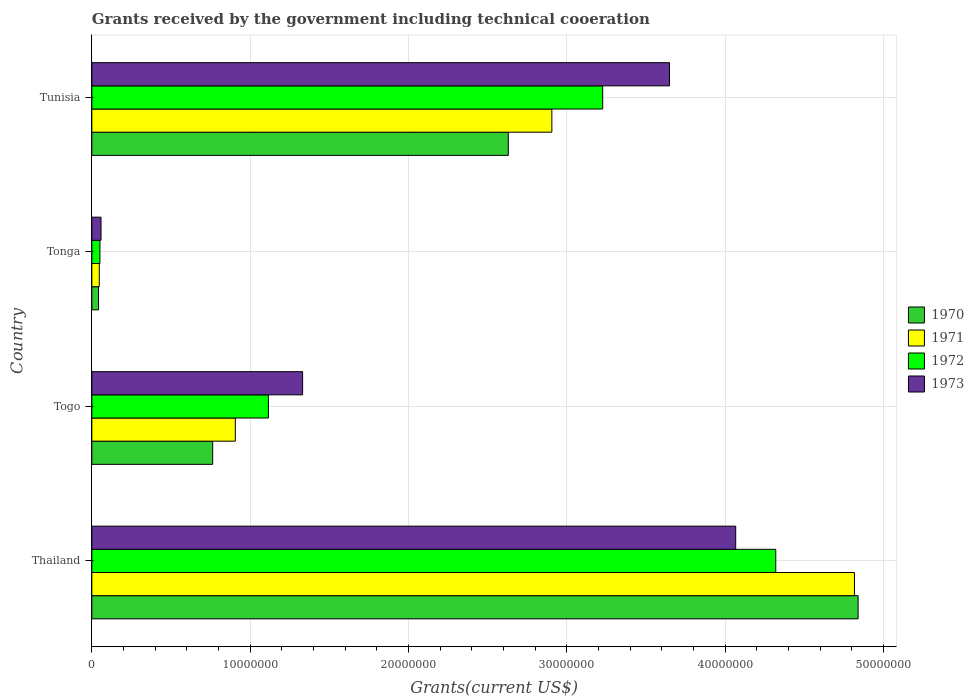How many different coloured bars are there?
Your response must be concise. 4. How many groups of bars are there?
Offer a very short reply. 4. Are the number of bars on each tick of the Y-axis equal?
Make the answer very short. Yes. How many bars are there on the 1st tick from the bottom?
Keep it short and to the point. 4. What is the label of the 1st group of bars from the top?
Keep it short and to the point. Tunisia. What is the total grants received by the government in 1972 in Thailand?
Your answer should be very brief. 4.32e+07. Across all countries, what is the maximum total grants received by the government in 1970?
Provide a short and direct response. 4.84e+07. Across all countries, what is the minimum total grants received by the government in 1973?
Make the answer very short. 5.80e+05. In which country was the total grants received by the government in 1972 maximum?
Offer a very short reply. Thailand. In which country was the total grants received by the government in 1973 minimum?
Offer a very short reply. Tonga. What is the total total grants received by the government in 1973 in the graph?
Provide a short and direct response. 9.10e+07. What is the difference between the total grants received by the government in 1972 in Thailand and that in Tunisia?
Provide a short and direct response. 1.09e+07. What is the difference between the total grants received by the government in 1971 in Tonga and the total grants received by the government in 1973 in Thailand?
Give a very brief answer. -4.02e+07. What is the average total grants received by the government in 1970 per country?
Offer a very short reply. 2.07e+07. What is the difference between the total grants received by the government in 1972 and total grants received by the government in 1970 in Togo?
Provide a succinct answer. 3.52e+06. In how many countries, is the total grants received by the government in 1972 greater than 28000000 US$?
Give a very brief answer. 2. What is the ratio of the total grants received by the government in 1972 in Tonga to that in Tunisia?
Provide a short and direct response. 0.02. Is the total grants received by the government in 1973 in Togo less than that in Tunisia?
Offer a very short reply. Yes. Is the difference between the total grants received by the government in 1972 in Tonga and Tunisia greater than the difference between the total grants received by the government in 1970 in Tonga and Tunisia?
Your answer should be very brief. No. What is the difference between the highest and the second highest total grants received by the government in 1973?
Provide a short and direct response. 4.18e+06. What is the difference between the highest and the lowest total grants received by the government in 1973?
Your answer should be compact. 4.01e+07. In how many countries, is the total grants received by the government in 1970 greater than the average total grants received by the government in 1970 taken over all countries?
Give a very brief answer. 2. Is the sum of the total grants received by the government in 1973 in Thailand and Togo greater than the maximum total grants received by the government in 1970 across all countries?
Provide a succinct answer. Yes. Is it the case that in every country, the sum of the total grants received by the government in 1973 and total grants received by the government in 1972 is greater than the sum of total grants received by the government in 1970 and total grants received by the government in 1971?
Your answer should be very brief. No. What does the 2nd bar from the bottom in Thailand represents?
Provide a succinct answer. 1971. Is it the case that in every country, the sum of the total grants received by the government in 1972 and total grants received by the government in 1971 is greater than the total grants received by the government in 1973?
Your response must be concise. Yes. How many bars are there?
Make the answer very short. 16. Are all the bars in the graph horizontal?
Your answer should be very brief. Yes. What is the difference between two consecutive major ticks on the X-axis?
Make the answer very short. 1.00e+07. Does the graph contain any zero values?
Provide a succinct answer. No. How many legend labels are there?
Keep it short and to the point. 4. What is the title of the graph?
Your answer should be compact. Grants received by the government including technical cooeration. What is the label or title of the X-axis?
Your answer should be compact. Grants(current US$). What is the Grants(current US$) in 1970 in Thailand?
Give a very brief answer. 4.84e+07. What is the Grants(current US$) in 1971 in Thailand?
Keep it short and to the point. 4.82e+07. What is the Grants(current US$) of 1972 in Thailand?
Your answer should be compact. 4.32e+07. What is the Grants(current US$) in 1973 in Thailand?
Your response must be concise. 4.07e+07. What is the Grants(current US$) of 1970 in Togo?
Your answer should be very brief. 7.63e+06. What is the Grants(current US$) of 1971 in Togo?
Make the answer very short. 9.06e+06. What is the Grants(current US$) in 1972 in Togo?
Offer a terse response. 1.12e+07. What is the Grants(current US$) of 1973 in Togo?
Make the answer very short. 1.33e+07. What is the Grants(current US$) of 1970 in Tonga?
Make the answer very short. 4.20e+05. What is the Grants(current US$) in 1972 in Tonga?
Make the answer very short. 5.10e+05. What is the Grants(current US$) of 1973 in Tonga?
Provide a short and direct response. 5.80e+05. What is the Grants(current US$) of 1970 in Tunisia?
Give a very brief answer. 2.63e+07. What is the Grants(current US$) in 1971 in Tunisia?
Provide a short and direct response. 2.90e+07. What is the Grants(current US$) of 1972 in Tunisia?
Your answer should be compact. 3.23e+07. What is the Grants(current US$) of 1973 in Tunisia?
Offer a very short reply. 3.65e+07. Across all countries, what is the maximum Grants(current US$) in 1970?
Ensure brevity in your answer.  4.84e+07. Across all countries, what is the maximum Grants(current US$) in 1971?
Keep it short and to the point. 4.82e+07. Across all countries, what is the maximum Grants(current US$) in 1972?
Your answer should be compact. 4.32e+07. Across all countries, what is the maximum Grants(current US$) of 1973?
Provide a succinct answer. 4.07e+07. Across all countries, what is the minimum Grants(current US$) in 1971?
Offer a terse response. 4.70e+05. Across all countries, what is the minimum Grants(current US$) of 1972?
Offer a terse response. 5.10e+05. Across all countries, what is the minimum Grants(current US$) in 1973?
Offer a very short reply. 5.80e+05. What is the total Grants(current US$) in 1970 in the graph?
Your answer should be compact. 8.27e+07. What is the total Grants(current US$) of 1971 in the graph?
Offer a very short reply. 8.67e+07. What is the total Grants(current US$) in 1972 in the graph?
Provide a short and direct response. 8.71e+07. What is the total Grants(current US$) of 1973 in the graph?
Make the answer very short. 9.10e+07. What is the difference between the Grants(current US$) of 1970 in Thailand and that in Togo?
Provide a short and direct response. 4.08e+07. What is the difference between the Grants(current US$) in 1971 in Thailand and that in Togo?
Provide a succinct answer. 3.91e+07. What is the difference between the Grants(current US$) in 1972 in Thailand and that in Togo?
Ensure brevity in your answer.  3.20e+07. What is the difference between the Grants(current US$) in 1973 in Thailand and that in Togo?
Ensure brevity in your answer.  2.74e+07. What is the difference between the Grants(current US$) in 1970 in Thailand and that in Tonga?
Provide a short and direct response. 4.80e+07. What is the difference between the Grants(current US$) of 1971 in Thailand and that in Tonga?
Your answer should be compact. 4.77e+07. What is the difference between the Grants(current US$) of 1972 in Thailand and that in Tonga?
Your response must be concise. 4.27e+07. What is the difference between the Grants(current US$) in 1973 in Thailand and that in Tonga?
Provide a short and direct response. 4.01e+07. What is the difference between the Grants(current US$) of 1970 in Thailand and that in Tunisia?
Your response must be concise. 2.21e+07. What is the difference between the Grants(current US$) in 1971 in Thailand and that in Tunisia?
Offer a very short reply. 1.91e+07. What is the difference between the Grants(current US$) of 1972 in Thailand and that in Tunisia?
Provide a succinct answer. 1.09e+07. What is the difference between the Grants(current US$) of 1973 in Thailand and that in Tunisia?
Give a very brief answer. 4.18e+06. What is the difference between the Grants(current US$) of 1970 in Togo and that in Tonga?
Your response must be concise. 7.21e+06. What is the difference between the Grants(current US$) in 1971 in Togo and that in Tonga?
Your answer should be very brief. 8.59e+06. What is the difference between the Grants(current US$) of 1972 in Togo and that in Tonga?
Give a very brief answer. 1.06e+07. What is the difference between the Grants(current US$) in 1973 in Togo and that in Tonga?
Your answer should be compact. 1.27e+07. What is the difference between the Grants(current US$) in 1970 in Togo and that in Tunisia?
Your answer should be compact. -1.87e+07. What is the difference between the Grants(current US$) of 1971 in Togo and that in Tunisia?
Provide a short and direct response. -2.00e+07. What is the difference between the Grants(current US$) of 1972 in Togo and that in Tunisia?
Ensure brevity in your answer.  -2.11e+07. What is the difference between the Grants(current US$) of 1973 in Togo and that in Tunisia?
Your answer should be very brief. -2.32e+07. What is the difference between the Grants(current US$) of 1970 in Tonga and that in Tunisia?
Give a very brief answer. -2.59e+07. What is the difference between the Grants(current US$) in 1971 in Tonga and that in Tunisia?
Offer a terse response. -2.86e+07. What is the difference between the Grants(current US$) of 1972 in Tonga and that in Tunisia?
Provide a succinct answer. -3.18e+07. What is the difference between the Grants(current US$) of 1973 in Tonga and that in Tunisia?
Offer a terse response. -3.59e+07. What is the difference between the Grants(current US$) in 1970 in Thailand and the Grants(current US$) in 1971 in Togo?
Give a very brief answer. 3.93e+07. What is the difference between the Grants(current US$) in 1970 in Thailand and the Grants(current US$) in 1972 in Togo?
Your answer should be compact. 3.72e+07. What is the difference between the Grants(current US$) in 1970 in Thailand and the Grants(current US$) in 1973 in Togo?
Provide a short and direct response. 3.51e+07. What is the difference between the Grants(current US$) of 1971 in Thailand and the Grants(current US$) of 1972 in Togo?
Keep it short and to the point. 3.70e+07. What is the difference between the Grants(current US$) of 1971 in Thailand and the Grants(current US$) of 1973 in Togo?
Your answer should be compact. 3.48e+07. What is the difference between the Grants(current US$) of 1972 in Thailand and the Grants(current US$) of 1973 in Togo?
Ensure brevity in your answer.  2.99e+07. What is the difference between the Grants(current US$) in 1970 in Thailand and the Grants(current US$) in 1971 in Tonga?
Offer a very short reply. 4.79e+07. What is the difference between the Grants(current US$) of 1970 in Thailand and the Grants(current US$) of 1972 in Tonga?
Provide a succinct answer. 4.79e+07. What is the difference between the Grants(current US$) in 1970 in Thailand and the Grants(current US$) in 1973 in Tonga?
Offer a terse response. 4.78e+07. What is the difference between the Grants(current US$) in 1971 in Thailand and the Grants(current US$) in 1972 in Tonga?
Your answer should be compact. 4.76e+07. What is the difference between the Grants(current US$) in 1971 in Thailand and the Grants(current US$) in 1973 in Tonga?
Give a very brief answer. 4.76e+07. What is the difference between the Grants(current US$) in 1972 in Thailand and the Grants(current US$) in 1973 in Tonga?
Your answer should be very brief. 4.26e+07. What is the difference between the Grants(current US$) in 1970 in Thailand and the Grants(current US$) in 1971 in Tunisia?
Offer a terse response. 1.93e+07. What is the difference between the Grants(current US$) of 1970 in Thailand and the Grants(current US$) of 1972 in Tunisia?
Keep it short and to the point. 1.61e+07. What is the difference between the Grants(current US$) of 1970 in Thailand and the Grants(current US$) of 1973 in Tunisia?
Provide a succinct answer. 1.19e+07. What is the difference between the Grants(current US$) in 1971 in Thailand and the Grants(current US$) in 1972 in Tunisia?
Ensure brevity in your answer.  1.59e+07. What is the difference between the Grants(current US$) of 1971 in Thailand and the Grants(current US$) of 1973 in Tunisia?
Ensure brevity in your answer.  1.17e+07. What is the difference between the Grants(current US$) in 1972 in Thailand and the Grants(current US$) in 1973 in Tunisia?
Offer a terse response. 6.71e+06. What is the difference between the Grants(current US$) in 1970 in Togo and the Grants(current US$) in 1971 in Tonga?
Offer a terse response. 7.16e+06. What is the difference between the Grants(current US$) of 1970 in Togo and the Grants(current US$) of 1972 in Tonga?
Provide a short and direct response. 7.12e+06. What is the difference between the Grants(current US$) of 1970 in Togo and the Grants(current US$) of 1973 in Tonga?
Ensure brevity in your answer.  7.05e+06. What is the difference between the Grants(current US$) of 1971 in Togo and the Grants(current US$) of 1972 in Tonga?
Your answer should be compact. 8.55e+06. What is the difference between the Grants(current US$) in 1971 in Togo and the Grants(current US$) in 1973 in Tonga?
Give a very brief answer. 8.48e+06. What is the difference between the Grants(current US$) of 1972 in Togo and the Grants(current US$) of 1973 in Tonga?
Offer a terse response. 1.06e+07. What is the difference between the Grants(current US$) of 1970 in Togo and the Grants(current US$) of 1971 in Tunisia?
Make the answer very short. -2.14e+07. What is the difference between the Grants(current US$) in 1970 in Togo and the Grants(current US$) in 1972 in Tunisia?
Your response must be concise. -2.46e+07. What is the difference between the Grants(current US$) of 1970 in Togo and the Grants(current US$) of 1973 in Tunisia?
Your response must be concise. -2.88e+07. What is the difference between the Grants(current US$) in 1971 in Togo and the Grants(current US$) in 1972 in Tunisia?
Make the answer very short. -2.32e+07. What is the difference between the Grants(current US$) of 1971 in Togo and the Grants(current US$) of 1973 in Tunisia?
Your response must be concise. -2.74e+07. What is the difference between the Grants(current US$) of 1972 in Togo and the Grants(current US$) of 1973 in Tunisia?
Keep it short and to the point. -2.53e+07. What is the difference between the Grants(current US$) in 1970 in Tonga and the Grants(current US$) in 1971 in Tunisia?
Offer a very short reply. -2.86e+07. What is the difference between the Grants(current US$) in 1970 in Tonga and the Grants(current US$) in 1972 in Tunisia?
Your answer should be very brief. -3.18e+07. What is the difference between the Grants(current US$) of 1970 in Tonga and the Grants(current US$) of 1973 in Tunisia?
Give a very brief answer. -3.61e+07. What is the difference between the Grants(current US$) in 1971 in Tonga and the Grants(current US$) in 1972 in Tunisia?
Ensure brevity in your answer.  -3.18e+07. What is the difference between the Grants(current US$) in 1971 in Tonga and the Grants(current US$) in 1973 in Tunisia?
Your answer should be compact. -3.60e+07. What is the difference between the Grants(current US$) in 1972 in Tonga and the Grants(current US$) in 1973 in Tunisia?
Provide a short and direct response. -3.60e+07. What is the average Grants(current US$) of 1970 per country?
Give a very brief answer. 2.07e+07. What is the average Grants(current US$) in 1971 per country?
Keep it short and to the point. 2.17e+07. What is the average Grants(current US$) of 1972 per country?
Your answer should be compact. 2.18e+07. What is the average Grants(current US$) of 1973 per country?
Keep it short and to the point. 2.28e+07. What is the difference between the Grants(current US$) of 1970 and Grants(current US$) of 1971 in Thailand?
Provide a short and direct response. 2.30e+05. What is the difference between the Grants(current US$) of 1970 and Grants(current US$) of 1972 in Thailand?
Offer a terse response. 5.20e+06. What is the difference between the Grants(current US$) in 1970 and Grants(current US$) in 1973 in Thailand?
Your answer should be compact. 7.73e+06. What is the difference between the Grants(current US$) of 1971 and Grants(current US$) of 1972 in Thailand?
Ensure brevity in your answer.  4.97e+06. What is the difference between the Grants(current US$) in 1971 and Grants(current US$) in 1973 in Thailand?
Make the answer very short. 7.50e+06. What is the difference between the Grants(current US$) in 1972 and Grants(current US$) in 1973 in Thailand?
Provide a short and direct response. 2.53e+06. What is the difference between the Grants(current US$) in 1970 and Grants(current US$) in 1971 in Togo?
Offer a terse response. -1.43e+06. What is the difference between the Grants(current US$) in 1970 and Grants(current US$) in 1972 in Togo?
Offer a terse response. -3.52e+06. What is the difference between the Grants(current US$) of 1970 and Grants(current US$) of 1973 in Togo?
Your answer should be very brief. -5.68e+06. What is the difference between the Grants(current US$) in 1971 and Grants(current US$) in 1972 in Togo?
Provide a short and direct response. -2.09e+06. What is the difference between the Grants(current US$) of 1971 and Grants(current US$) of 1973 in Togo?
Your response must be concise. -4.25e+06. What is the difference between the Grants(current US$) of 1972 and Grants(current US$) of 1973 in Togo?
Give a very brief answer. -2.16e+06. What is the difference between the Grants(current US$) of 1970 and Grants(current US$) of 1972 in Tonga?
Your response must be concise. -9.00e+04. What is the difference between the Grants(current US$) of 1970 and Grants(current US$) of 1973 in Tonga?
Make the answer very short. -1.60e+05. What is the difference between the Grants(current US$) in 1971 and Grants(current US$) in 1972 in Tonga?
Provide a short and direct response. -4.00e+04. What is the difference between the Grants(current US$) in 1971 and Grants(current US$) in 1973 in Tonga?
Give a very brief answer. -1.10e+05. What is the difference between the Grants(current US$) in 1970 and Grants(current US$) in 1971 in Tunisia?
Ensure brevity in your answer.  -2.75e+06. What is the difference between the Grants(current US$) of 1970 and Grants(current US$) of 1972 in Tunisia?
Keep it short and to the point. -5.96e+06. What is the difference between the Grants(current US$) of 1970 and Grants(current US$) of 1973 in Tunisia?
Provide a succinct answer. -1.02e+07. What is the difference between the Grants(current US$) in 1971 and Grants(current US$) in 1972 in Tunisia?
Give a very brief answer. -3.21e+06. What is the difference between the Grants(current US$) in 1971 and Grants(current US$) in 1973 in Tunisia?
Keep it short and to the point. -7.43e+06. What is the difference between the Grants(current US$) of 1972 and Grants(current US$) of 1973 in Tunisia?
Provide a succinct answer. -4.22e+06. What is the ratio of the Grants(current US$) of 1970 in Thailand to that in Togo?
Your response must be concise. 6.34. What is the ratio of the Grants(current US$) of 1971 in Thailand to that in Togo?
Ensure brevity in your answer.  5.32. What is the ratio of the Grants(current US$) of 1972 in Thailand to that in Togo?
Your response must be concise. 3.87. What is the ratio of the Grants(current US$) in 1973 in Thailand to that in Togo?
Offer a terse response. 3.05. What is the ratio of the Grants(current US$) of 1970 in Thailand to that in Tonga?
Your answer should be compact. 115.21. What is the ratio of the Grants(current US$) of 1971 in Thailand to that in Tonga?
Offer a terse response. 102.47. What is the ratio of the Grants(current US$) in 1972 in Thailand to that in Tonga?
Provide a succinct answer. 84.69. What is the ratio of the Grants(current US$) of 1973 in Thailand to that in Tonga?
Offer a terse response. 70.1. What is the ratio of the Grants(current US$) of 1970 in Thailand to that in Tunisia?
Your answer should be compact. 1.84. What is the ratio of the Grants(current US$) in 1971 in Thailand to that in Tunisia?
Provide a short and direct response. 1.66. What is the ratio of the Grants(current US$) in 1972 in Thailand to that in Tunisia?
Offer a terse response. 1.34. What is the ratio of the Grants(current US$) of 1973 in Thailand to that in Tunisia?
Give a very brief answer. 1.11. What is the ratio of the Grants(current US$) of 1970 in Togo to that in Tonga?
Give a very brief answer. 18.17. What is the ratio of the Grants(current US$) of 1971 in Togo to that in Tonga?
Provide a short and direct response. 19.28. What is the ratio of the Grants(current US$) in 1972 in Togo to that in Tonga?
Ensure brevity in your answer.  21.86. What is the ratio of the Grants(current US$) of 1973 in Togo to that in Tonga?
Make the answer very short. 22.95. What is the ratio of the Grants(current US$) of 1970 in Togo to that in Tunisia?
Ensure brevity in your answer.  0.29. What is the ratio of the Grants(current US$) in 1971 in Togo to that in Tunisia?
Ensure brevity in your answer.  0.31. What is the ratio of the Grants(current US$) of 1972 in Togo to that in Tunisia?
Ensure brevity in your answer.  0.35. What is the ratio of the Grants(current US$) of 1973 in Togo to that in Tunisia?
Ensure brevity in your answer.  0.36. What is the ratio of the Grants(current US$) in 1970 in Tonga to that in Tunisia?
Make the answer very short. 0.02. What is the ratio of the Grants(current US$) in 1971 in Tonga to that in Tunisia?
Provide a short and direct response. 0.02. What is the ratio of the Grants(current US$) of 1972 in Tonga to that in Tunisia?
Give a very brief answer. 0.02. What is the ratio of the Grants(current US$) of 1973 in Tonga to that in Tunisia?
Make the answer very short. 0.02. What is the difference between the highest and the second highest Grants(current US$) of 1970?
Ensure brevity in your answer.  2.21e+07. What is the difference between the highest and the second highest Grants(current US$) in 1971?
Your answer should be compact. 1.91e+07. What is the difference between the highest and the second highest Grants(current US$) in 1972?
Your response must be concise. 1.09e+07. What is the difference between the highest and the second highest Grants(current US$) in 1973?
Make the answer very short. 4.18e+06. What is the difference between the highest and the lowest Grants(current US$) in 1970?
Your answer should be compact. 4.80e+07. What is the difference between the highest and the lowest Grants(current US$) in 1971?
Offer a very short reply. 4.77e+07. What is the difference between the highest and the lowest Grants(current US$) of 1972?
Offer a very short reply. 4.27e+07. What is the difference between the highest and the lowest Grants(current US$) in 1973?
Your answer should be compact. 4.01e+07. 